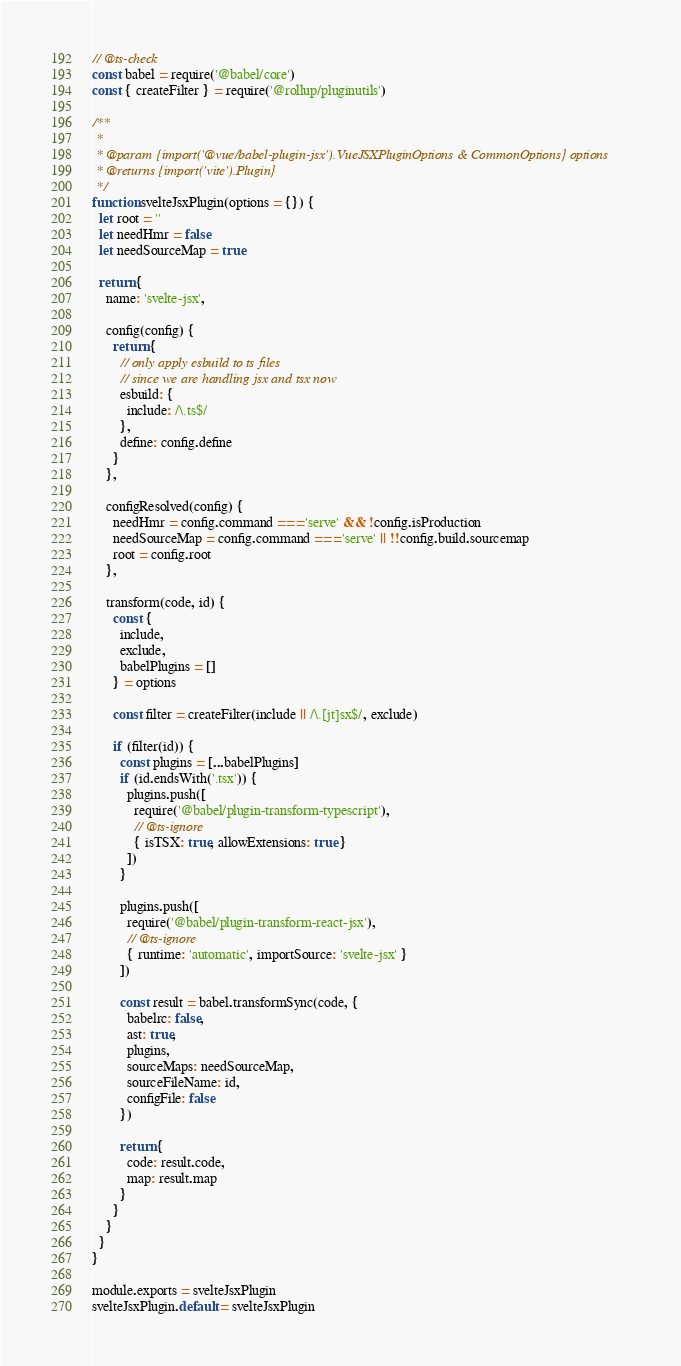<code> <loc_0><loc_0><loc_500><loc_500><_JavaScript_>// @ts-check
const babel = require('@babel/core')
const { createFilter } = require('@rollup/pluginutils')

/**
 *
 * @param {import('@vue/babel-plugin-jsx').VueJSXPluginOptions & CommonOptions} options
 * @returns {import('vite').Plugin}
 */
function svelteJsxPlugin(options = {}) {
  let root = ''
  let needHmr = false
  let needSourceMap = true

  return {
    name: 'svelte-jsx',

    config(config) {
      return {
        // only apply esbuild to ts files
        // since we are handling jsx and tsx now
        esbuild: {
          include: /\.ts$/
        },
        define: config.define
      }
    },

    configResolved(config) {
      needHmr = config.command === 'serve' && !config.isProduction
      needSourceMap = config.command === 'serve' || !!config.build.sourcemap
      root = config.root
    },

    transform(code, id) {
      const {
        include,
        exclude,
        babelPlugins = []
      } = options

      const filter = createFilter(include || /\.[jt]sx$/, exclude)

      if (filter(id)) {
        const plugins = [...babelPlugins]
        if (id.endsWith('.tsx')) {
          plugins.push([
            require('@babel/plugin-transform-typescript'),
            // @ts-ignore
            { isTSX: true, allowExtensions: true }
          ])
        }

        plugins.push([
          require('@babel/plugin-transform-react-jsx'),
          // @ts-ignore
          { runtime: 'automatic', importSource: 'svelte-jsx' }
        ])

        const result = babel.transformSync(code, {
          babelrc: false,
          ast: true,
          plugins,
          sourceMaps: needSourceMap,
          sourceFileName: id,
          configFile: false
        })

        return {
          code: result.code,
          map: result.map
        }
      }
    }
  }
}

module.exports = svelteJsxPlugin
svelteJsxPlugin.default = svelteJsxPlugin
</code> 